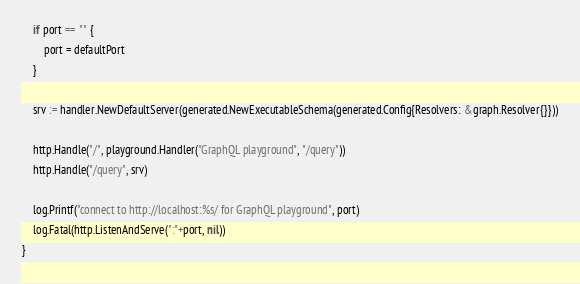Convert code to text. <code><loc_0><loc_0><loc_500><loc_500><_Go_>	if port == "" {
		port = defaultPort
	}

	srv := handler.NewDefaultServer(generated.NewExecutableSchema(generated.Config{Resolvers: &graph.Resolver{}}))

	http.Handle("/", playground.Handler("GraphQL playground", "/query"))
	http.Handle("/query", srv)

	log.Printf("connect to http://localhost:%s/ for GraphQL playground", port)
	log.Fatal(http.ListenAndServe(":"+port, nil))
}
</code> 